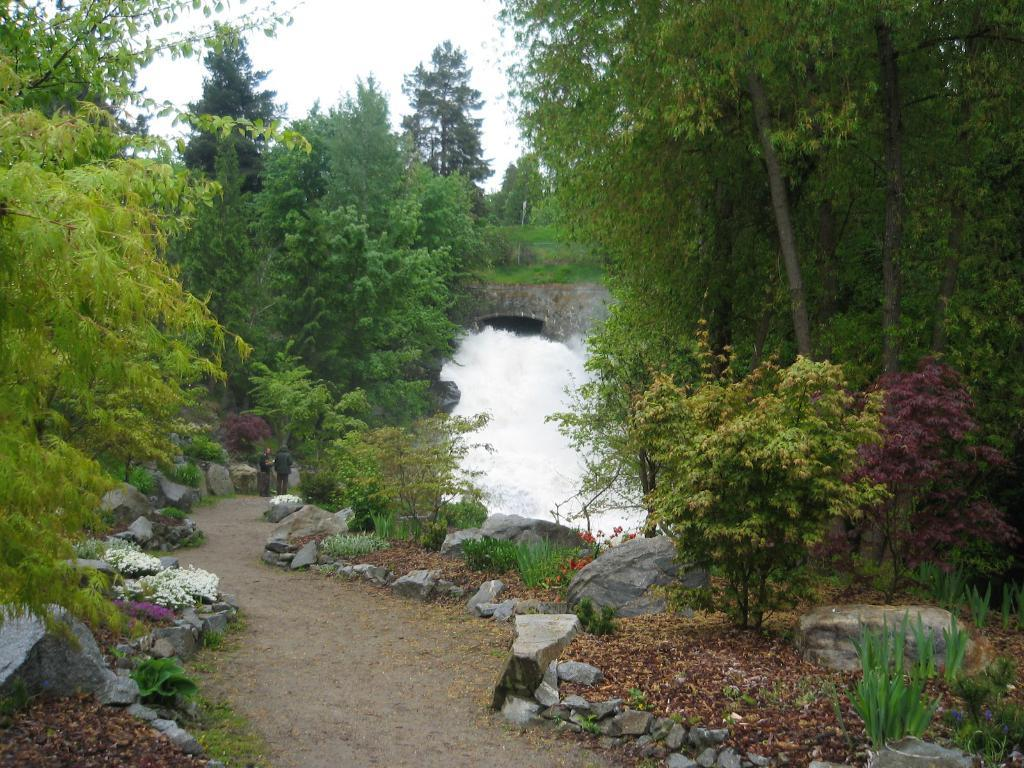How many people are in the image? There are two people in the image. Where are the people located in the image? The people are on a path in the image. What can be seen beside the path? There are stones beside the path. What type of vegetation is present in the image? There are plants in the image. What is visible in the background of the image? There are trees and the sky visible in the background of the image. What type of story is being told by the people in the image? There is no story being told by the people in the image; they are simply walking on a path. What type of mask is being worn by the plants in the image? There are no masks present in the image; the plants are not wearing any masks. 